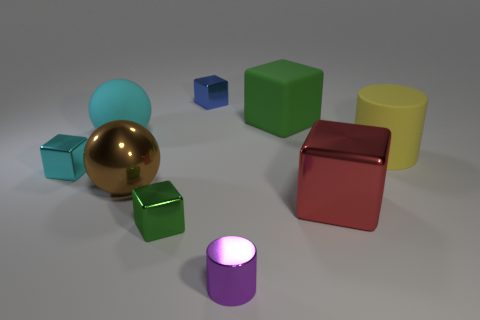How do the colors of the objects contribute to the overall feel of the image? The colors of the objects offer a playful and diverse palette, with bright primaries and pastel tones contrasted against the neutral background. This creates a visually engaging and harmonious composition that feels balanced and inviting. Do any of the objects seem out of place? Not particularly. Each object's color and size appear intentionally chosen to contribute positively to the overall aesthetic of the scene. The assortment of shapes and colors seems to suggest an environment designed for visual appeal or perhaps a set-up for a specific purpose, such as a color or material study. 